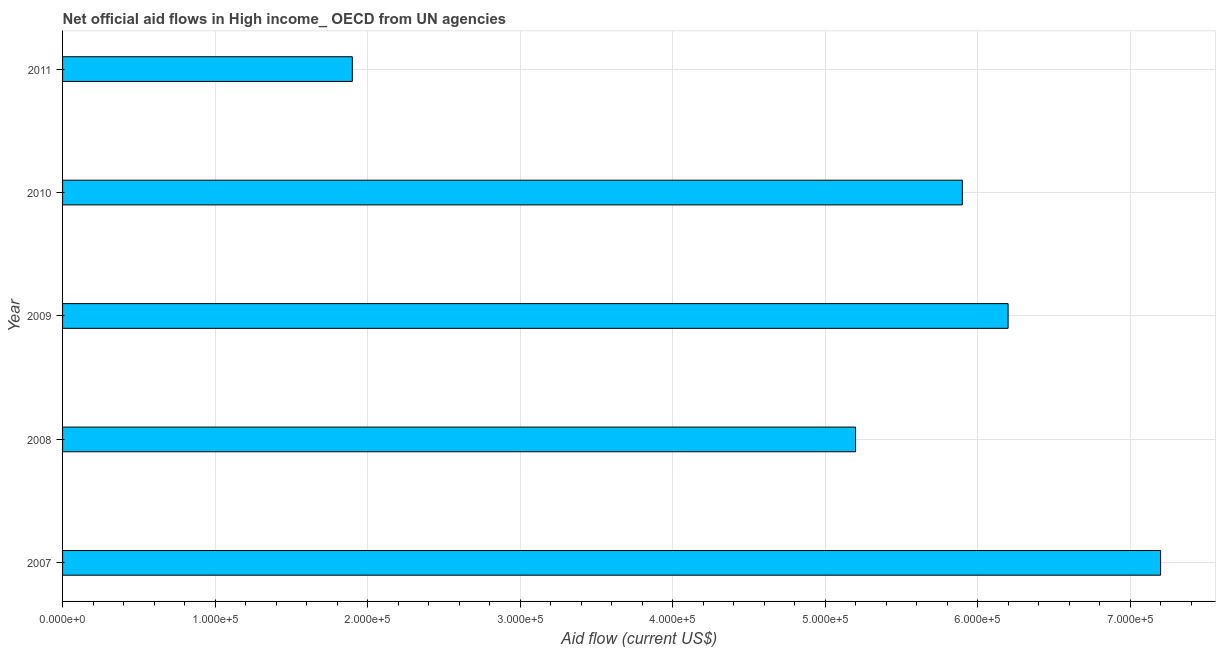Does the graph contain any zero values?
Your response must be concise. No. What is the title of the graph?
Give a very brief answer. Net official aid flows in High income_ OECD from UN agencies. What is the label or title of the Y-axis?
Ensure brevity in your answer.  Year. What is the net official flows from un agencies in 2011?
Keep it short and to the point. 1.90e+05. Across all years, what is the maximum net official flows from un agencies?
Make the answer very short. 7.20e+05. In which year was the net official flows from un agencies minimum?
Your answer should be compact. 2011. What is the sum of the net official flows from un agencies?
Your answer should be compact. 2.64e+06. What is the difference between the net official flows from un agencies in 2007 and 2009?
Keep it short and to the point. 1.00e+05. What is the average net official flows from un agencies per year?
Ensure brevity in your answer.  5.28e+05. What is the median net official flows from un agencies?
Offer a terse response. 5.90e+05. In how many years, is the net official flows from un agencies greater than 360000 US$?
Offer a terse response. 4. Do a majority of the years between 2011 and 2010 (inclusive) have net official flows from un agencies greater than 400000 US$?
Your response must be concise. No. What is the ratio of the net official flows from un agencies in 2007 to that in 2010?
Make the answer very short. 1.22. Is the difference between the net official flows from un agencies in 2007 and 2008 greater than the difference between any two years?
Offer a very short reply. No. What is the difference between the highest and the second highest net official flows from un agencies?
Make the answer very short. 1.00e+05. Is the sum of the net official flows from un agencies in 2009 and 2010 greater than the maximum net official flows from un agencies across all years?
Provide a succinct answer. Yes. What is the difference between the highest and the lowest net official flows from un agencies?
Your response must be concise. 5.30e+05. In how many years, is the net official flows from un agencies greater than the average net official flows from un agencies taken over all years?
Ensure brevity in your answer.  3. What is the difference between two consecutive major ticks on the X-axis?
Your response must be concise. 1.00e+05. What is the Aid flow (current US$) of 2007?
Give a very brief answer. 7.20e+05. What is the Aid flow (current US$) in 2008?
Your answer should be compact. 5.20e+05. What is the Aid flow (current US$) in 2009?
Provide a short and direct response. 6.20e+05. What is the Aid flow (current US$) of 2010?
Ensure brevity in your answer.  5.90e+05. What is the difference between the Aid flow (current US$) in 2007 and 2010?
Keep it short and to the point. 1.30e+05. What is the difference between the Aid flow (current US$) in 2007 and 2011?
Give a very brief answer. 5.30e+05. What is the difference between the Aid flow (current US$) in 2008 and 2010?
Your answer should be very brief. -7.00e+04. What is the difference between the Aid flow (current US$) in 2008 and 2011?
Your response must be concise. 3.30e+05. What is the difference between the Aid flow (current US$) in 2010 and 2011?
Give a very brief answer. 4.00e+05. What is the ratio of the Aid flow (current US$) in 2007 to that in 2008?
Your answer should be very brief. 1.39. What is the ratio of the Aid flow (current US$) in 2007 to that in 2009?
Your response must be concise. 1.16. What is the ratio of the Aid flow (current US$) in 2007 to that in 2010?
Your answer should be very brief. 1.22. What is the ratio of the Aid flow (current US$) in 2007 to that in 2011?
Ensure brevity in your answer.  3.79. What is the ratio of the Aid flow (current US$) in 2008 to that in 2009?
Ensure brevity in your answer.  0.84. What is the ratio of the Aid flow (current US$) in 2008 to that in 2010?
Your answer should be very brief. 0.88. What is the ratio of the Aid flow (current US$) in 2008 to that in 2011?
Your answer should be compact. 2.74. What is the ratio of the Aid flow (current US$) in 2009 to that in 2010?
Provide a short and direct response. 1.05. What is the ratio of the Aid flow (current US$) in 2009 to that in 2011?
Provide a succinct answer. 3.26. What is the ratio of the Aid flow (current US$) in 2010 to that in 2011?
Offer a very short reply. 3.1. 